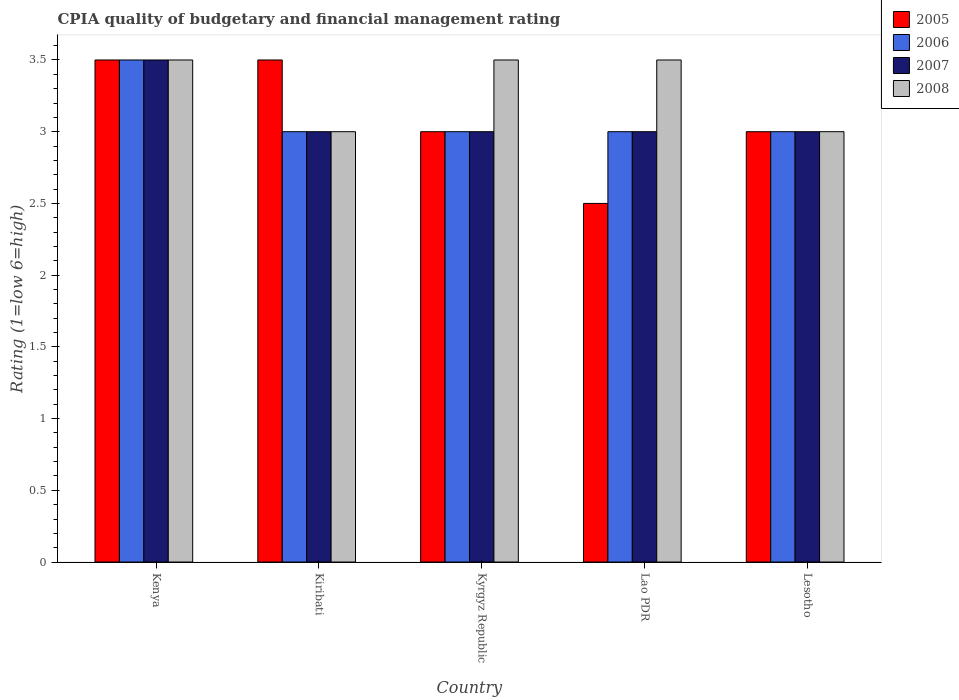How many groups of bars are there?
Ensure brevity in your answer.  5. Are the number of bars on each tick of the X-axis equal?
Your answer should be very brief. Yes. How many bars are there on the 4th tick from the right?
Provide a succinct answer. 4. What is the label of the 5th group of bars from the left?
Keep it short and to the point. Lesotho. In which country was the CPIA rating in 2007 maximum?
Keep it short and to the point. Kenya. In which country was the CPIA rating in 2008 minimum?
Your response must be concise. Kiribati. What is the total CPIA rating in 2006 in the graph?
Your response must be concise. 15.5. What is the difference between the CPIA rating in 2005 in Kiribati and that in Lesotho?
Offer a terse response. 0.5. What is the average CPIA rating in 2005 per country?
Your answer should be compact. 3.1. In how many countries, is the CPIA rating in 2005 greater than 1.9?
Your answer should be compact. 5. Is the CPIA rating in 2006 in Kyrgyz Republic less than that in Lao PDR?
Make the answer very short. No. What is the difference between the highest and the second highest CPIA rating in 2006?
Make the answer very short. -0.5. In how many countries, is the CPIA rating in 2005 greater than the average CPIA rating in 2005 taken over all countries?
Offer a very short reply. 2. What does the 2nd bar from the left in Lesotho represents?
Your answer should be very brief. 2006. Is it the case that in every country, the sum of the CPIA rating in 2005 and CPIA rating in 2007 is greater than the CPIA rating in 2008?
Provide a short and direct response. Yes. How many countries are there in the graph?
Your answer should be compact. 5. Are the values on the major ticks of Y-axis written in scientific E-notation?
Offer a terse response. No. Does the graph contain grids?
Ensure brevity in your answer.  No. Where does the legend appear in the graph?
Offer a very short reply. Top right. How are the legend labels stacked?
Your response must be concise. Vertical. What is the title of the graph?
Your answer should be compact. CPIA quality of budgetary and financial management rating. Does "1978" appear as one of the legend labels in the graph?
Give a very brief answer. No. What is the Rating (1=low 6=high) of 2007 in Kenya?
Your answer should be very brief. 3.5. What is the Rating (1=low 6=high) in 2008 in Kenya?
Make the answer very short. 3.5. What is the Rating (1=low 6=high) of 2005 in Kiribati?
Provide a succinct answer. 3.5. What is the Rating (1=low 6=high) of 2005 in Kyrgyz Republic?
Offer a very short reply. 3. What is the Rating (1=low 6=high) in 2006 in Kyrgyz Republic?
Give a very brief answer. 3. What is the Rating (1=low 6=high) of 2005 in Lao PDR?
Your response must be concise. 2.5. What is the Rating (1=low 6=high) in 2008 in Lao PDR?
Provide a succinct answer. 3.5. Across all countries, what is the maximum Rating (1=low 6=high) in 2006?
Provide a succinct answer. 3.5. Across all countries, what is the minimum Rating (1=low 6=high) in 2005?
Your answer should be very brief. 2.5. What is the total Rating (1=low 6=high) of 2005 in the graph?
Provide a short and direct response. 15.5. What is the total Rating (1=low 6=high) in 2006 in the graph?
Your response must be concise. 15.5. What is the total Rating (1=low 6=high) in 2007 in the graph?
Give a very brief answer. 15.5. What is the total Rating (1=low 6=high) in 2008 in the graph?
Keep it short and to the point. 16.5. What is the difference between the Rating (1=low 6=high) in 2006 in Kenya and that in Kiribati?
Offer a very short reply. 0.5. What is the difference between the Rating (1=low 6=high) of 2007 in Kenya and that in Kiribati?
Offer a terse response. 0.5. What is the difference between the Rating (1=low 6=high) in 2007 in Kenya and that in Kyrgyz Republic?
Give a very brief answer. 0.5. What is the difference between the Rating (1=low 6=high) in 2008 in Kenya and that in Kyrgyz Republic?
Provide a succinct answer. 0. What is the difference between the Rating (1=low 6=high) of 2008 in Kenya and that in Lao PDR?
Offer a terse response. 0. What is the difference between the Rating (1=low 6=high) of 2005 in Kenya and that in Lesotho?
Ensure brevity in your answer.  0.5. What is the difference between the Rating (1=low 6=high) in 2006 in Kiribati and that in Kyrgyz Republic?
Provide a short and direct response. 0. What is the difference between the Rating (1=low 6=high) of 2007 in Kiribati and that in Kyrgyz Republic?
Your response must be concise. 0. What is the difference between the Rating (1=low 6=high) of 2005 in Kiribati and that in Lao PDR?
Your answer should be compact. 1. What is the difference between the Rating (1=low 6=high) of 2007 in Kiribati and that in Lao PDR?
Your response must be concise. 0. What is the difference between the Rating (1=low 6=high) in 2006 in Kiribati and that in Lesotho?
Offer a very short reply. 0. What is the difference between the Rating (1=low 6=high) of 2008 in Kiribati and that in Lesotho?
Offer a very short reply. 0. What is the difference between the Rating (1=low 6=high) of 2005 in Kyrgyz Republic and that in Lao PDR?
Your answer should be very brief. 0.5. What is the difference between the Rating (1=low 6=high) in 2008 in Kyrgyz Republic and that in Lao PDR?
Provide a succinct answer. 0. What is the difference between the Rating (1=low 6=high) of 2005 in Kyrgyz Republic and that in Lesotho?
Your answer should be very brief. 0. What is the difference between the Rating (1=low 6=high) in 2006 in Kyrgyz Republic and that in Lesotho?
Make the answer very short. 0. What is the difference between the Rating (1=low 6=high) of 2007 in Kyrgyz Republic and that in Lesotho?
Give a very brief answer. 0. What is the difference between the Rating (1=low 6=high) in 2008 in Kyrgyz Republic and that in Lesotho?
Offer a terse response. 0.5. What is the difference between the Rating (1=low 6=high) of 2005 in Lao PDR and that in Lesotho?
Give a very brief answer. -0.5. What is the difference between the Rating (1=low 6=high) of 2007 in Lao PDR and that in Lesotho?
Your response must be concise. 0. What is the difference between the Rating (1=low 6=high) of 2008 in Lao PDR and that in Lesotho?
Your answer should be compact. 0.5. What is the difference between the Rating (1=low 6=high) in 2005 in Kenya and the Rating (1=low 6=high) in 2008 in Kiribati?
Your answer should be very brief. 0.5. What is the difference between the Rating (1=low 6=high) in 2007 in Kenya and the Rating (1=low 6=high) in 2008 in Kiribati?
Provide a short and direct response. 0.5. What is the difference between the Rating (1=low 6=high) of 2005 in Kenya and the Rating (1=low 6=high) of 2007 in Kyrgyz Republic?
Your answer should be compact. 0.5. What is the difference between the Rating (1=low 6=high) in 2005 in Kenya and the Rating (1=low 6=high) in 2008 in Kyrgyz Republic?
Keep it short and to the point. 0. What is the difference between the Rating (1=low 6=high) of 2006 in Kenya and the Rating (1=low 6=high) of 2007 in Kyrgyz Republic?
Keep it short and to the point. 0.5. What is the difference between the Rating (1=low 6=high) in 2005 in Kenya and the Rating (1=low 6=high) in 2008 in Lao PDR?
Offer a very short reply. 0. What is the difference between the Rating (1=low 6=high) in 2006 in Kenya and the Rating (1=low 6=high) in 2007 in Lao PDR?
Provide a succinct answer. 0.5. What is the difference between the Rating (1=low 6=high) in 2007 in Kenya and the Rating (1=low 6=high) in 2008 in Lao PDR?
Offer a very short reply. 0. What is the difference between the Rating (1=low 6=high) of 2006 in Kenya and the Rating (1=low 6=high) of 2008 in Lesotho?
Offer a terse response. 0.5. What is the difference between the Rating (1=low 6=high) in 2007 in Kenya and the Rating (1=low 6=high) in 2008 in Lesotho?
Ensure brevity in your answer.  0.5. What is the difference between the Rating (1=low 6=high) in 2005 in Kiribati and the Rating (1=low 6=high) in 2007 in Kyrgyz Republic?
Offer a very short reply. 0.5. What is the difference between the Rating (1=low 6=high) of 2005 in Kiribati and the Rating (1=low 6=high) of 2008 in Kyrgyz Republic?
Your answer should be compact. 0. What is the difference between the Rating (1=low 6=high) of 2007 in Kiribati and the Rating (1=low 6=high) of 2008 in Kyrgyz Republic?
Give a very brief answer. -0.5. What is the difference between the Rating (1=low 6=high) in 2005 in Kiribati and the Rating (1=low 6=high) in 2006 in Lao PDR?
Your answer should be compact. 0.5. What is the difference between the Rating (1=low 6=high) of 2006 in Kiribati and the Rating (1=low 6=high) of 2008 in Lao PDR?
Give a very brief answer. -0.5. What is the difference between the Rating (1=low 6=high) in 2005 in Kiribati and the Rating (1=low 6=high) in 2008 in Lesotho?
Your answer should be compact. 0.5. What is the difference between the Rating (1=low 6=high) of 2006 in Kiribati and the Rating (1=low 6=high) of 2007 in Lesotho?
Provide a short and direct response. 0. What is the difference between the Rating (1=low 6=high) in 2006 in Kiribati and the Rating (1=low 6=high) in 2008 in Lesotho?
Keep it short and to the point. 0. What is the difference between the Rating (1=low 6=high) of 2005 in Kyrgyz Republic and the Rating (1=low 6=high) of 2008 in Lao PDR?
Provide a short and direct response. -0.5. What is the difference between the Rating (1=low 6=high) in 2006 in Kyrgyz Republic and the Rating (1=low 6=high) in 2008 in Lao PDR?
Keep it short and to the point. -0.5. What is the difference between the Rating (1=low 6=high) of 2007 in Kyrgyz Republic and the Rating (1=low 6=high) of 2008 in Lao PDR?
Keep it short and to the point. -0.5. What is the difference between the Rating (1=low 6=high) of 2005 in Kyrgyz Republic and the Rating (1=low 6=high) of 2007 in Lesotho?
Ensure brevity in your answer.  0. What is the difference between the Rating (1=low 6=high) in 2006 in Kyrgyz Republic and the Rating (1=low 6=high) in 2008 in Lesotho?
Provide a short and direct response. 0. What is the difference between the Rating (1=low 6=high) of 2007 in Kyrgyz Republic and the Rating (1=low 6=high) of 2008 in Lesotho?
Offer a very short reply. 0. What is the difference between the Rating (1=low 6=high) in 2005 in Lao PDR and the Rating (1=low 6=high) in 2008 in Lesotho?
Keep it short and to the point. -0.5. What is the difference between the Rating (1=low 6=high) of 2006 in Lao PDR and the Rating (1=low 6=high) of 2008 in Lesotho?
Provide a succinct answer. 0. What is the average Rating (1=low 6=high) of 2005 per country?
Keep it short and to the point. 3.1. What is the average Rating (1=low 6=high) in 2007 per country?
Keep it short and to the point. 3.1. What is the difference between the Rating (1=low 6=high) of 2005 and Rating (1=low 6=high) of 2006 in Kenya?
Give a very brief answer. 0. What is the difference between the Rating (1=low 6=high) of 2005 and Rating (1=low 6=high) of 2007 in Kenya?
Your response must be concise. 0. What is the difference between the Rating (1=low 6=high) of 2007 and Rating (1=low 6=high) of 2008 in Kenya?
Offer a terse response. 0. What is the difference between the Rating (1=low 6=high) in 2005 and Rating (1=low 6=high) in 2006 in Kiribati?
Your answer should be very brief. 0.5. What is the difference between the Rating (1=low 6=high) of 2005 and Rating (1=low 6=high) of 2007 in Kiribati?
Offer a very short reply. 0.5. What is the difference between the Rating (1=low 6=high) in 2005 and Rating (1=low 6=high) in 2008 in Kiribati?
Provide a succinct answer. 0.5. What is the difference between the Rating (1=low 6=high) of 2006 and Rating (1=low 6=high) of 2007 in Kiribati?
Your answer should be compact. 0. What is the difference between the Rating (1=low 6=high) in 2006 and Rating (1=low 6=high) in 2008 in Kiribati?
Your answer should be compact. 0. What is the difference between the Rating (1=low 6=high) in 2005 and Rating (1=low 6=high) in 2006 in Kyrgyz Republic?
Provide a short and direct response. 0. What is the difference between the Rating (1=low 6=high) in 2005 and Rating (1=low 6=high) in 2007 in Kyrgyz Republic?
Your answer should be compact. 0. What is the difference between the Rating (1=low 6=high) in 2005 and Rating (1=low 6=high) in 2008 in Kyrgyz Republic?
Ensure brevity in your answer.  -0.5. What is the difference between the Rating (1=low 6=high) of 2005 and Rating (1=low 6=high) of 2008 in Lao PDR?
Keep it short and to the point. -1. What is the difference between the Rating (1=low 6=high) of 2006 and Rating (1=low 6=high) of 2007 in Lao PDR?
Offer a very short reply. 0. What is the difference between the Rating (1=low 6=high) in 2006 and Rating (1=low 6=high) in 2008 in Lao PDR?
Provide a succinct answer. -0.5. What is the difference between the Rating (1=low 6=high) in 2006 and Rating (1=low 6=high) in 2008 in Lesotho?
Your response must be concise. 0. What is the ratio of the Rating (1=low 6=high) in 2005 in Kenya to that in Kiribati?
Offer a terse response. 1. What is the ratio of the Rating (1=low 6=high) of 2006 in Kenya to that in Kiribati?
Give a very brief answer. 1.17. What is the ratio of the Rating (1=low 6=high) of 2006 in Kenya to that in Kyrgyz Republic?
Your response must be concise. 1.17. What is the ratio of the Rating (1=low 6=high) in 2005 in Kenya to that in Lao PDR?
Offer a very short reply. 1.4. What is the ratio of the Rating (1=low 6=high) of 2005 in Kenya to that in Lesotho?
Your answer should be compact. 1.17. What is the ratio of the Rating (1=low 6=high) of 2006 in Kenya to that in Lesotho?
Ensure brevity in your answer.  1.17. What is the ratio of the Rating (1=low 6=high) in 2005 in Kiribati to that in Kyrgyz Republic?
Keep it short and to the point. 1.17. What is the ratio of the Rating (1=low 6=high) of 2008 in Kiribati to that in Kyrgyz Republic?
Make the answer very short. 0.86. What is the ratio of the Rating (1=low 6=high) of 2005 in Kiribati to that in Lao PDR?
Ensure brevity in your answer.  1.4. What is the ratio of the Rating (1=low 6=high) of 2007 in Kiribati to that in Lao PDR?
Make the answer very short. 1. What is the ratio of the Rating (1=low 6=high) in 2008 in Kiribati to that in Lao PDR?
Ensure brevity in your answer.  0.86. What is the ratio of the Rating (1=low 6=high) in 2006 in Kiribati to that in Lesotho?
Provide a succinct answer. 1. What is the ratio of the Rating (1=low 6=high) in 2007 in Kiribati to that in Lesotho?
Your answer should be very brief. 1. What is the ratio of the Rating (1=low 6=high) of 2008 in Kiribati to that in Lesotho?
Give a very brief answer. 1. What is the ratio of the Rating (1=low 6=high) in 2006 in Kyrgyz Republic to that in Lao PDR?
Your response must be concise. 1. What is the ratio of the Rating (1=low 6=high) of 2007 in Kyrgyz Republic to that in Lao PDR?
Provide a succinct answer. 1. What is the ratio of the Rating (1=low 6=high) in 2008 in Kyrgyz Republic to that in Lao PDR?
Your response must be concise. 1. What is the ratio of the Rating (1=low 6=high) in 2005 in Kyrgyz Republic to that in Lesotho?
Offer a very short reply. 1. What is the ratio of the Rating (1=low 6=high) of 2006 in Kyrgyz Republic to that in Lesotho?
Make the answer very short. 1. What is the ratio of the Rating (1=low 6=high) of 2008 in Kyrgyz Republic to that in Lesotho?
Make the answer very short. 1.17. What is the ratio of the Rating (1=low 6=high) of 2005 in Lao PDR to that in Lesotho?
Your answer should be very brief. 0.83. What is the ratio of the Rating (1=low 6=high) in 2006 in Lao PDR to that in Lesotho?
Ensure brevity in your answer.  1. What is the ratio of the Rating (1=low 6=high) of 2007 in Lao PDR to that in Lesotho?
Offer a very short reply. 1. What is the difference between the highest and the second highest Rating (1=low 6=high) of 2005?
Offer a very short reply. 0. What is the difference between the highest and the second highest Rating (1=low 6=high) of 2007?
Offer a very short reply. 0.5. What is the difference between the highest and the second highest Rating (1=low 6=high) in 2008?
Keep it short and to the point. 0. What is the difference between the highest and the lowest Rating (1=low 6=high) of 2008?
Your answer should be compact. 0.5. 